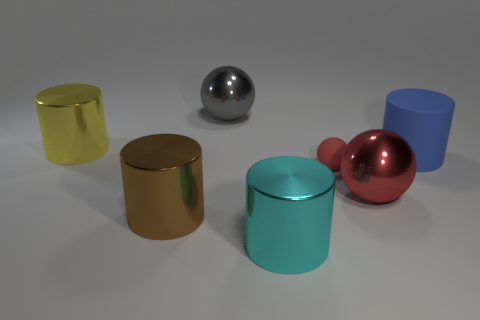The big thing that is the same color as the tiny matte ball is what shape? sphere 